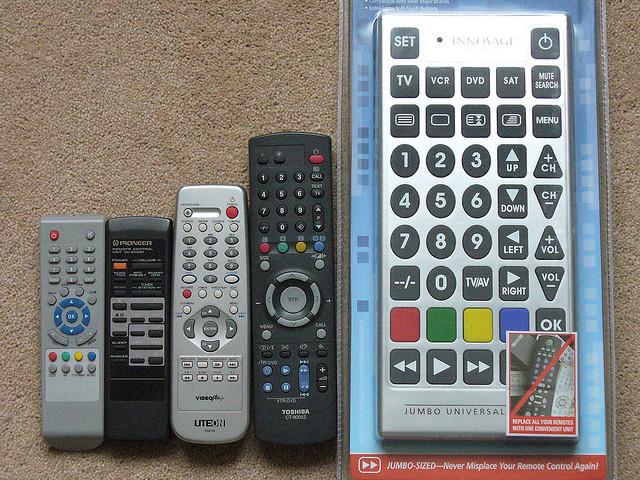How many remotes are there?
Concise answer only. 5. Which remote has the least amount of colored buttons?
Give a very brief answer. Black 1. Is this a small remote?
Keep it brief. No. What shape are the numbered buttons on the largest remote?
Give a very brief answer. Round. Is this a phone?
Give a very brief answer. No. 